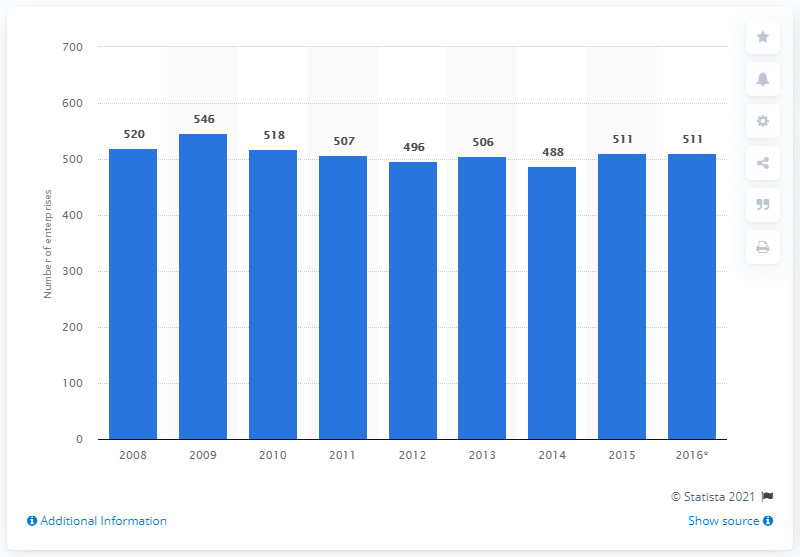Indicate a few pertinent items in this graphic. In 2015, there were 511 enterprises in Bulgaria that manufactured paper and paper products. 